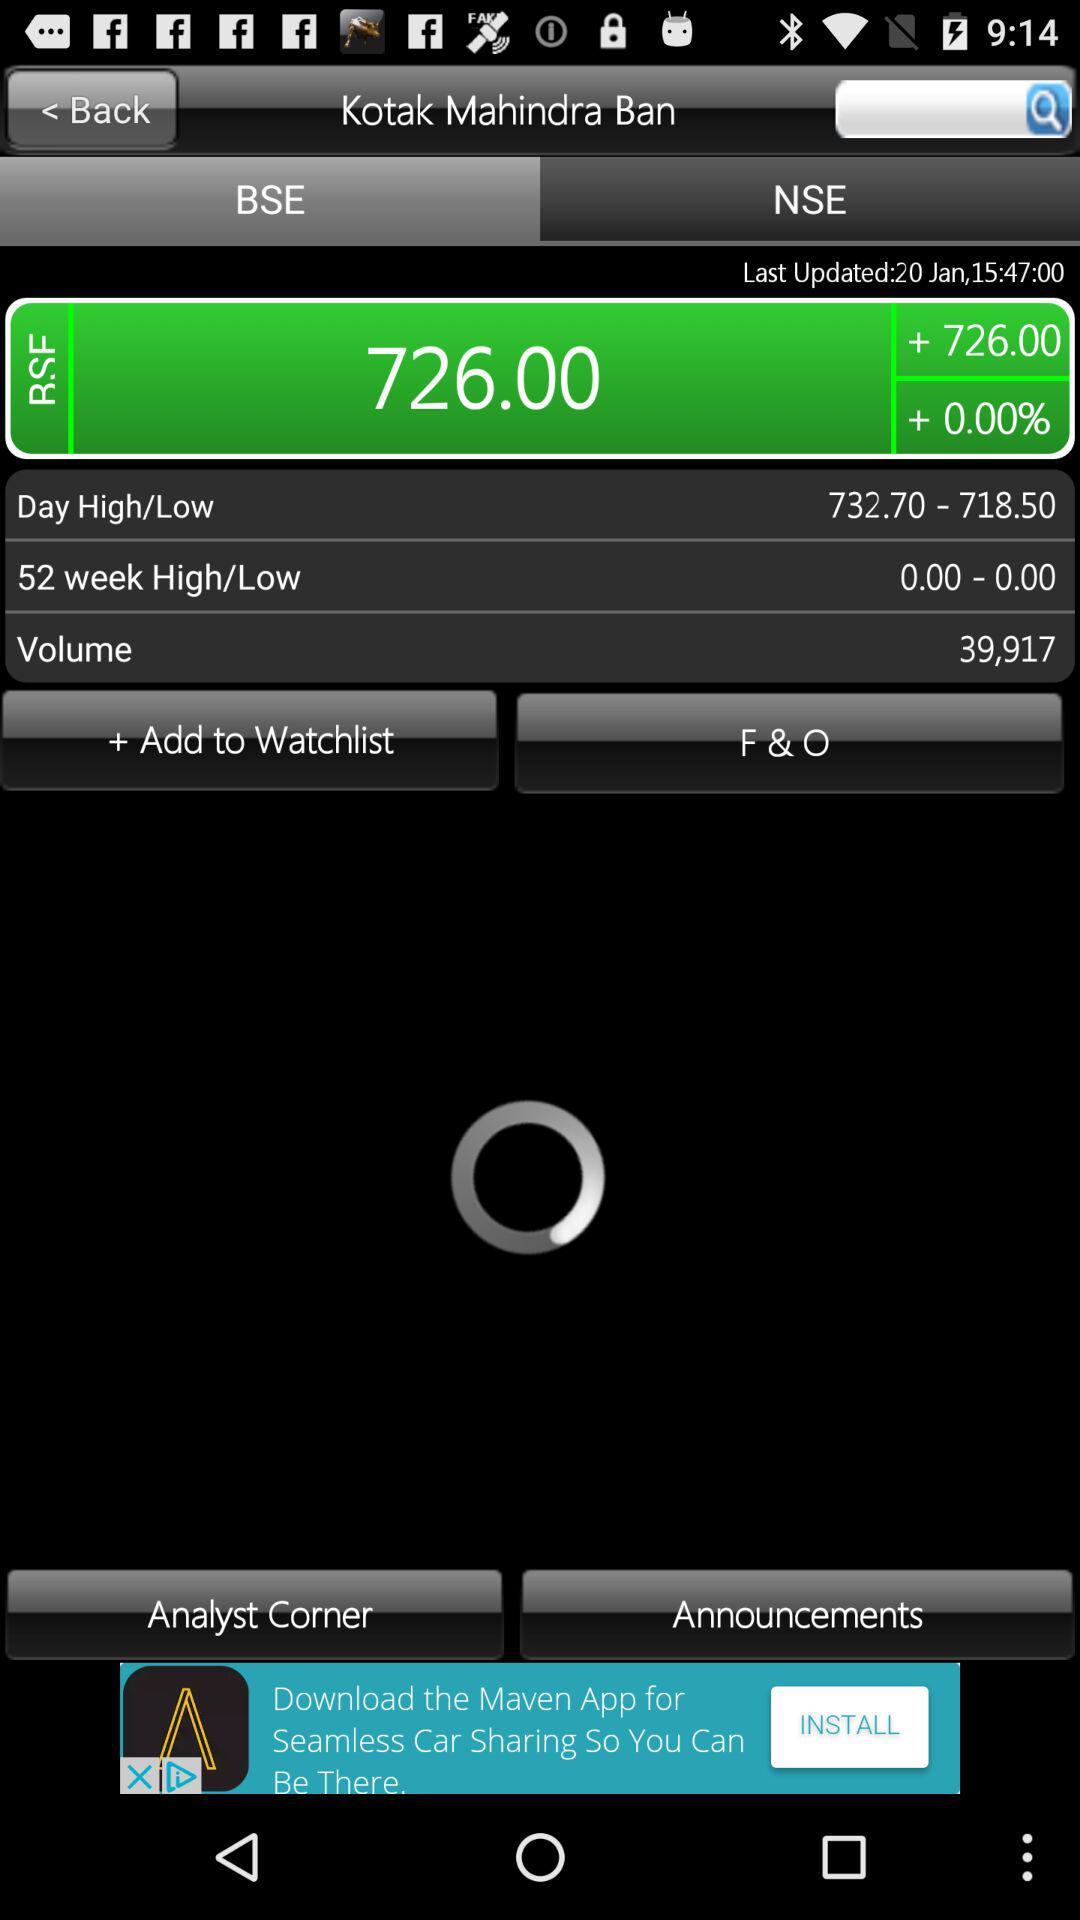What is the volume of Kotak Mahindra Bank?
Answer the question using a single word or phrase. 39,917 